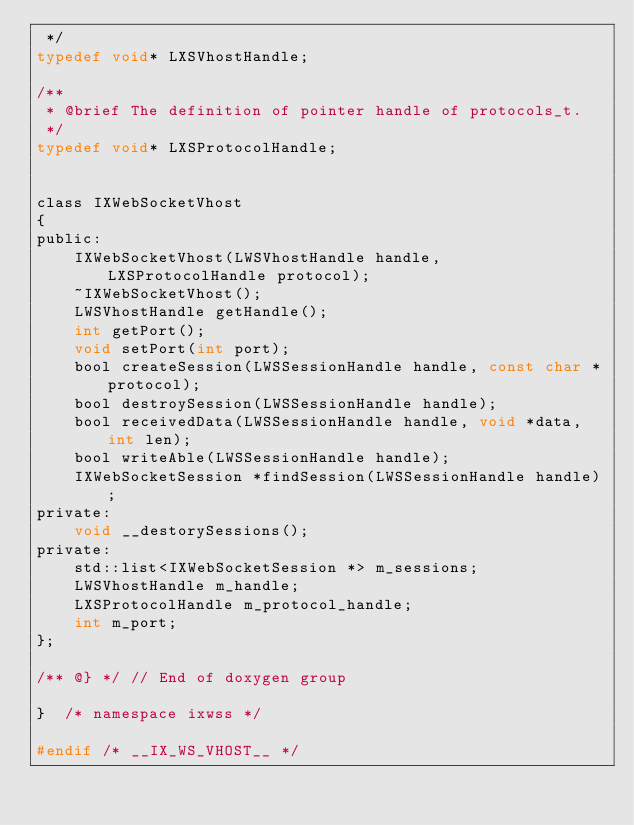<code> <loc_0><loc_0><loc_500><loc_500><_C_> */
typedef void* LXSVhostHandle;

/** 
 * @brief The definition of pointer handle of protocols_t. 
 */
typedef void* LXSProtocolHandle;


class IXWebSocketVhost
{
public:
    IXWebSocketVhost(LWSVhostHandle handle, LXSProtocolHandle protocol);
    ~IXWebSocketVhost();
    LWSVhostHandle getHandle();
    int getPort();
    void setPort(int port);
    bool createSession(LWSSessionHandle handle, const char *protocol);
    bool destroySession(LWSSessionHandle handle);
    bool receivedData(LWSSessionHandle handle, void *data, int len);
    bool writeAble(LWSSessionHandle handle);
    IXWebSocketSession *findSession(LWSSessionHandle handle);
private:
    void __destorySessions(); 
private:
    std::list<IXWebSocketSession *> m_sessions;
    LWSVhostHandle m_handle;
    LXSProtocolHandle m_protocol_handle; 
    int m_port;
};

/** @} */ // End of doxygen group

}  /* namespace ixwss */

#endif /* __IX_WS_VHOST__ */</code> 